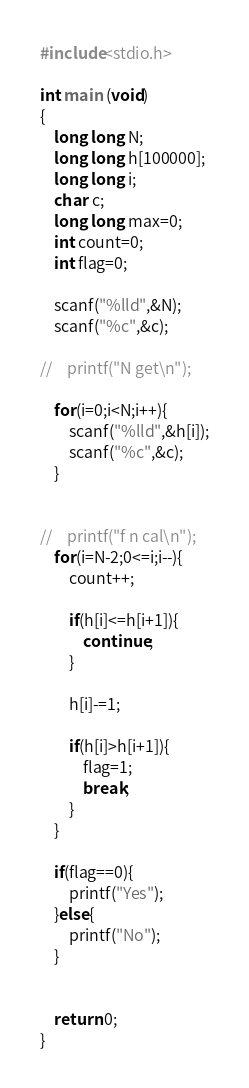Convert code to text. <code><loc_0><loc_0><loc_500><loc_500><_C_>#include<stdio.h>

int main (void)
{
    long long N;
    long long h[100000];
    long long i;
    char c;
    long long max=0;
    int count=0;
    int flag=0;

    scanf("%lld",&N);
    scanf("%c",&c);

//    printf("N get\n");

    for(i=0;i<N;i++){
        scanf("%lld",&h[i]);
        scanf("%c",&c);
    }


//    printf("f n cal\n");
    for(i=N-2;0<=i;i--){
        count++;

        if(h[i]<=h[i+1]){
            continue;
        }

        h[i]-=1;

        if(h[i]>h[i+1]){
            flag=1;
            break;
        }
    }

    if(flag==0){
        printf("Yes");
    }else{
        printf("No");
    }


    return 0;
}</code> 